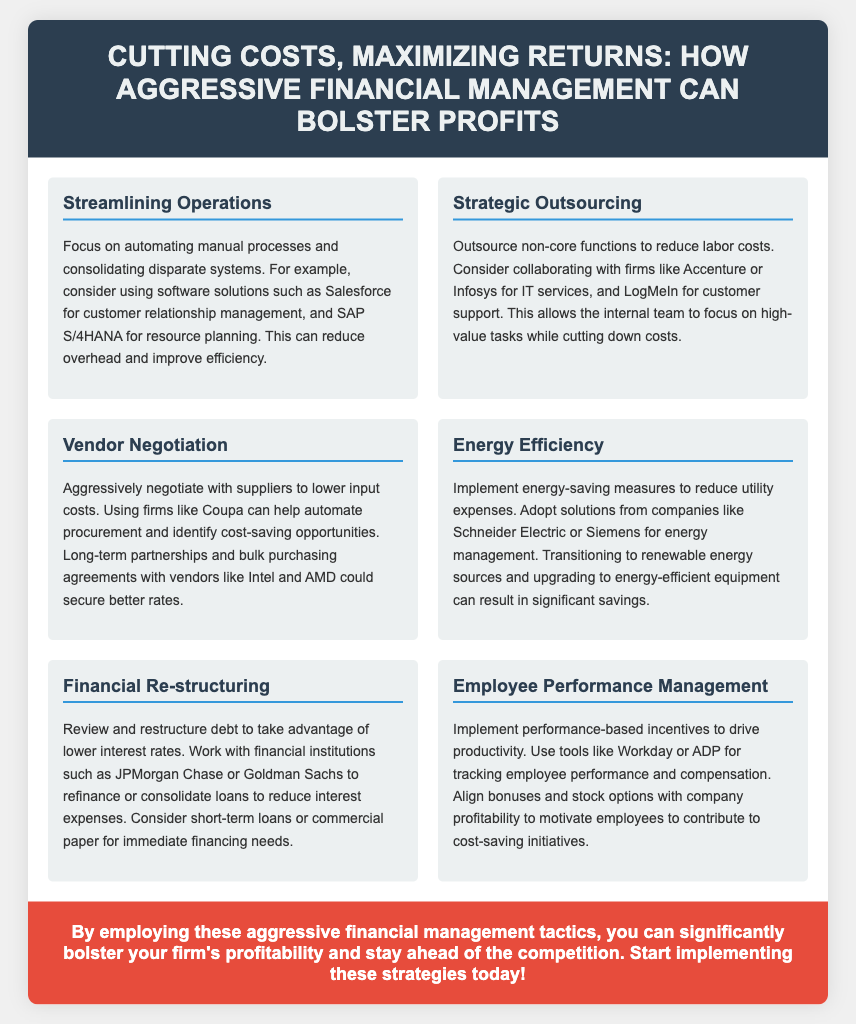What is the title of the flyer? The title of the flyer is stated prominently at the top of the document.
Answer: Cutting Costs, Maximizing Returns: How Aggressive Financial Management Can Bolster Profits Which company is suggested for IT services outsourcing? The document lists specific firms to consider for outsourcing IT services in the strategic outsourcing section.
Answer: Accenture What is the main focus of the energy efficiency section? The energy efficiency section highlights specific actions to reduce utility expenses through energy-saving measures.
Answer: Implement energy-saving measures Which financial institution is mentioned for refinancing loans? The document references particular financial institutions for debt restructuring in the financial restructuring section.
Answer: JPMorgan Chase What tool is recommended for tracking employee performance? The document suggests tools specifically designed for monitoring employee performance and compensation in the employee performance management section.
Answer: Workday What approach is suggested for vendor negotiation? The document outlines a specific tactic to qualify the vendor negotiation process effectively.
Answer: Aggressively negotiate How many content sections are included in the flyer? The total number of sections presented in the content area counts the subsections discussing various strategies.
Answer: Six 